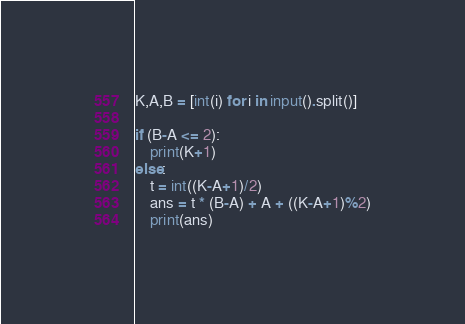Convert code to text. <code><loc_0><loc_0><loc_500><loc_500><_Python_>K,A,B = [int(i) for i in input().split()]

if (B-A <= 2):
    print(K+1)
else:
    t = int((K-A+1)/2)
    ans = t * (B-A) + A + ((K-A+1)%2)
    print(ans)
</code> 